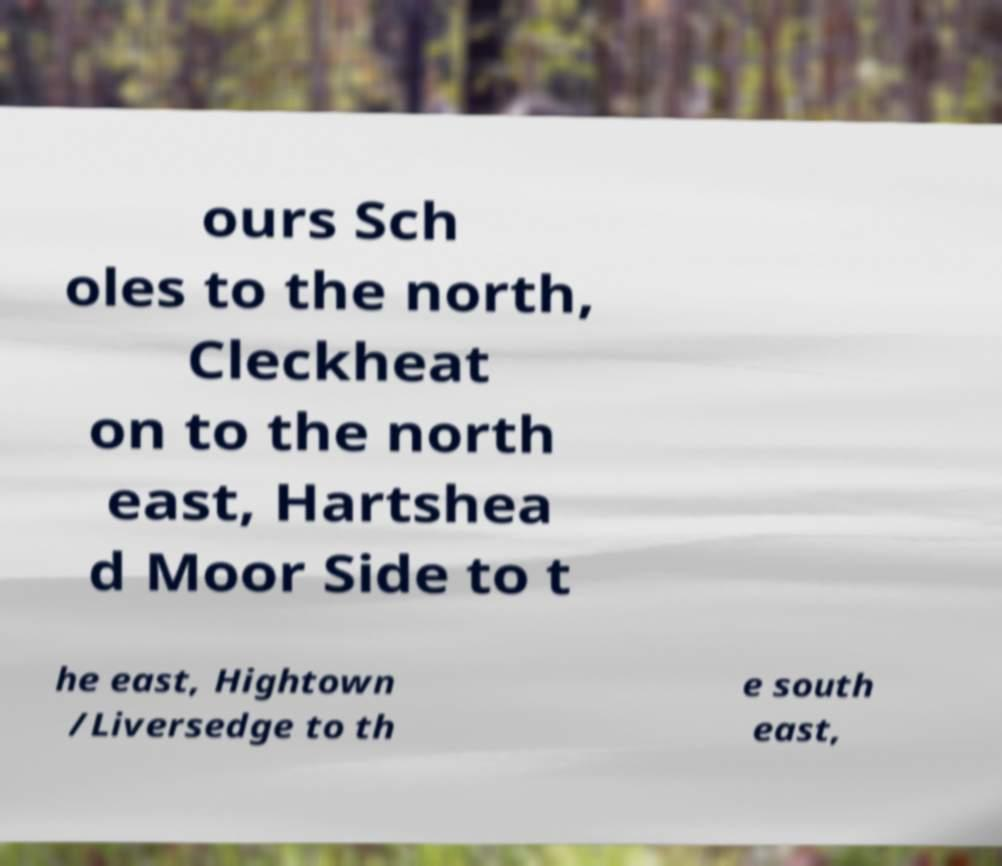There's text embedded in this image that I need extracted. Can you transcribe it verbatim? ours Sch oles to the north, Cleckheat on to the north east, Hartshea d Moor Side to t he east, Hightown /Liversedge to th e south east, 